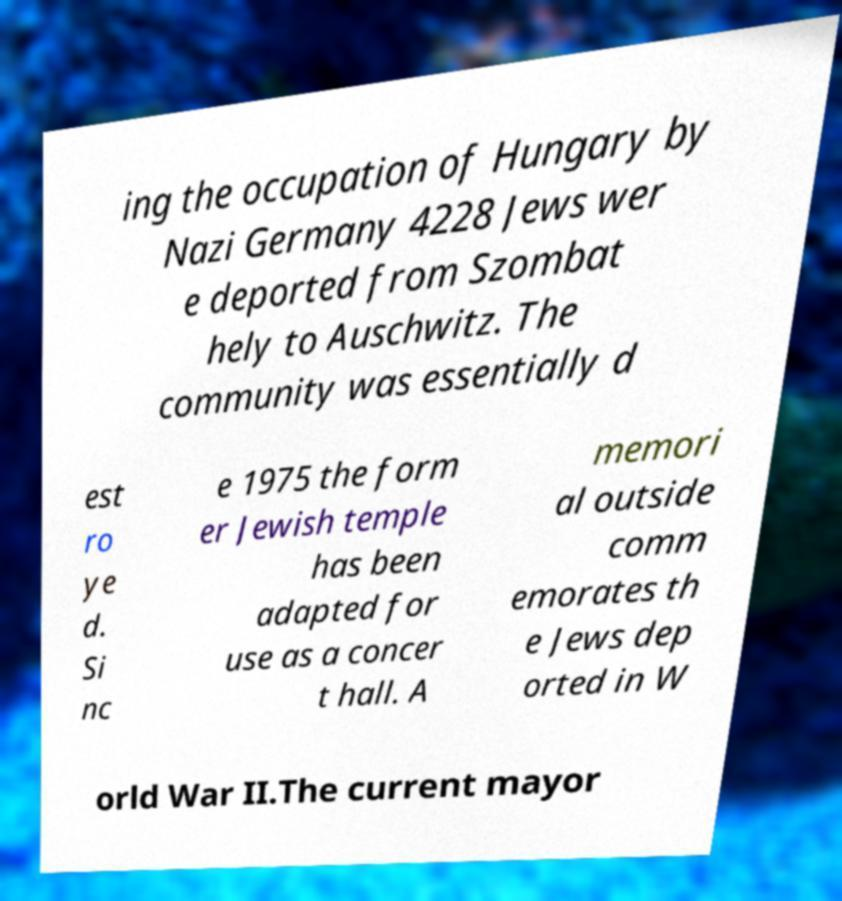I need the written content from this picture converted into text. Can you do that? ing the occupation of Hungary by Nazi Germany 4228 Jews wer e deported from Szombat hely to Auschwitz. The community was essentially d est ro ye d. Si nc e 1975 the form er Jewish temple has been adapted for use as a concer t hall. A memori al outside comm emorates th e Jews dep orted in W orld War II.The current mayor 